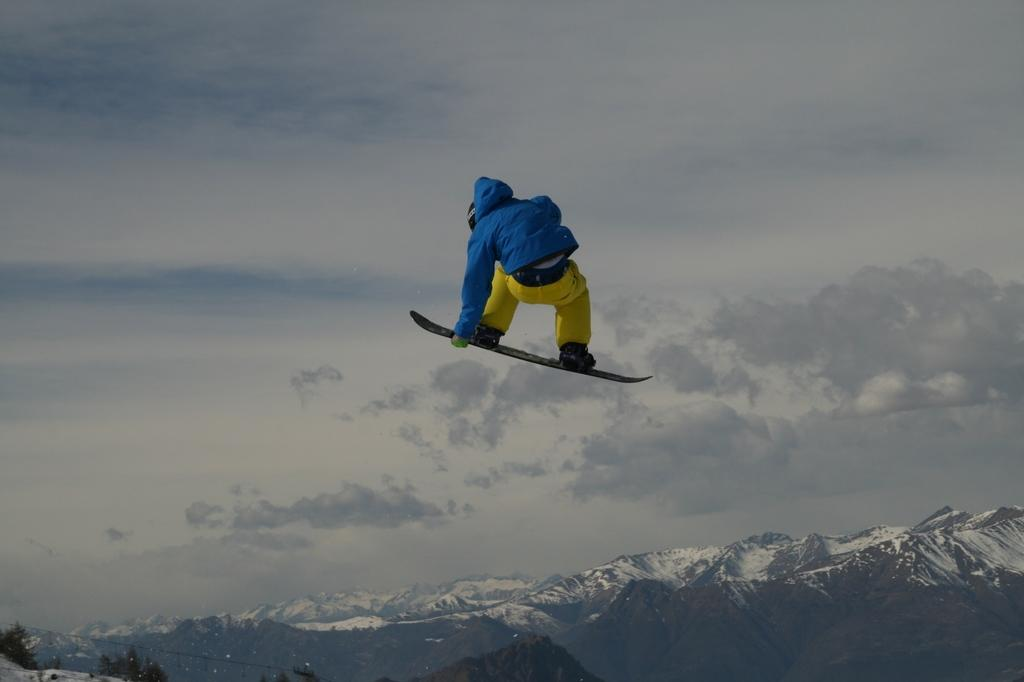What is the main subject of the image? There is a person in the image. What is the person doing in the image? The person is on ski blades. What can be seen in the background of the image? There are mountains, trees, and the sky visible in the background of the image. How many maids are present in the image? There are no maids present in the image; it features a person on ski blades in a mountainous landscape. What is the amount of street visible in the image? There is no street visible in the image; it is set in a natural, outdoor environment. 